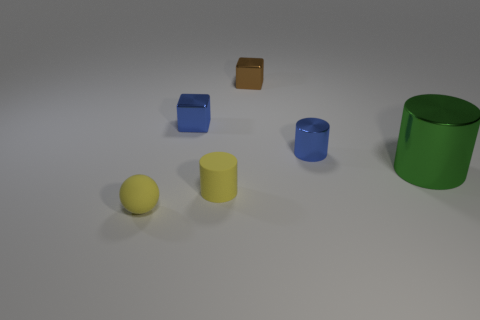Add 4 tiny blue metal things. How many objects exist? 10 Subtract all spheres. How many objects are left? 5 Subtract 0 blue spheres. How many objects are left? 6 Subtract all purple shiny spheres. Subtract all tiny yellow rubber things. How many objects are left? 4 Add 1 small brown cubes. How many small brown cubes are left? 2 Add 5 yellow rubber cylinders. How many yellow rubber cylinders exist? 6 